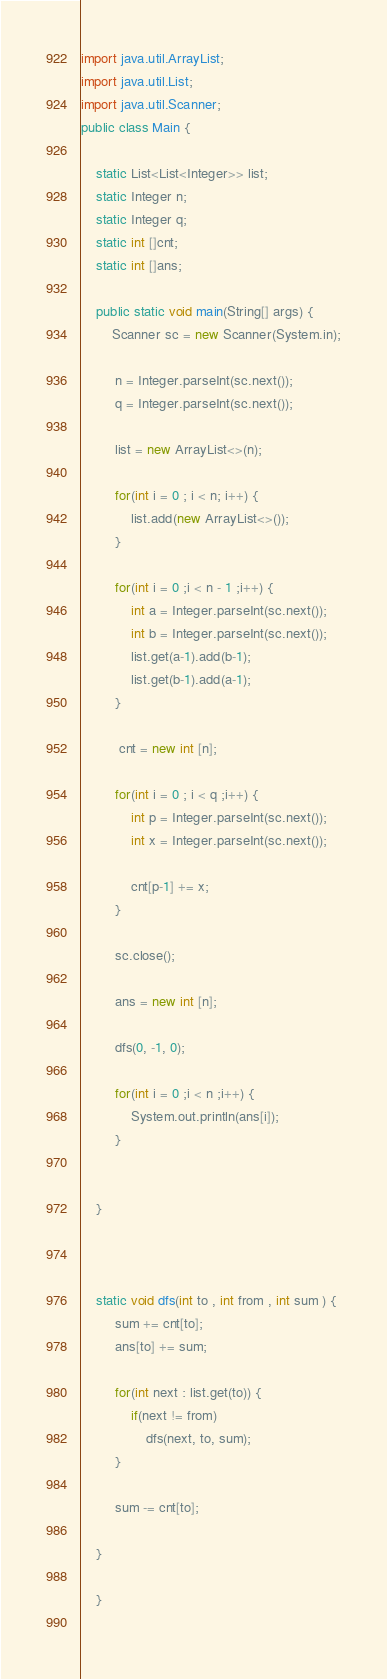Convert code to text. <code><loc_0><loc_0><loc_500><loc_500><_Java_>
import java.util.ArrayList;
import java.util.List;
import java.util.Scanner;
public class Main {
	
	static List<List<Integer>> list;
	static Integer n;
	static Integer q;
	static int []cnt;
	static int []ans;
	
	public static void main(String[] args) {
		Scanner sc = new Scanner(System.in);
		
		 n = Integer.parseInt(sc.next());
		 q = Integer.parseInt(sc.next());
		
		 list = new ArrayList<>(n);
		 
		 for(int i = 0 ; i < n; i++) {
			 list.add(new ArrayList<>());
		 }
		 
		 for(int i = 0 ;i < n - 1 ;i++) {
			 int a = Integer.parseInt(sc.next());
			 int b = Integer.parseInt(sc.next());
			 list.get(a-1).add(b-1);
			 list.get(b-1).add(a-1);
		 }
		 
		  cnt = new int [n];
		 
		 for(int i = 0 ; i < q ;i++) {
			 int p = Integer.parseInt(sc.next());
			 int x = Integer.parseInt(sc.next());
			 
			 cnt[p-1] += x;
		 }
		 
		 sc.close();
		 
		 ans = new int [n];
		 
		 dfs(0, -1, 0);
		 
		 for(int i = 0 ;i < n ;i++) {
			 System.out.println(ans[i]);
		 }
		 

	}

	
	
	static void dfs(int to , int from , int sum ) {
		 sum += cnt[to];
		 ans[to] += sum;
		 
		 for(int next : list.get(to)) {
			 if(next != from)
				 dfs(next, to, sum);
		 }
		 
		 sum -= cnt[to];
		 
	}

	}
	
</code> 